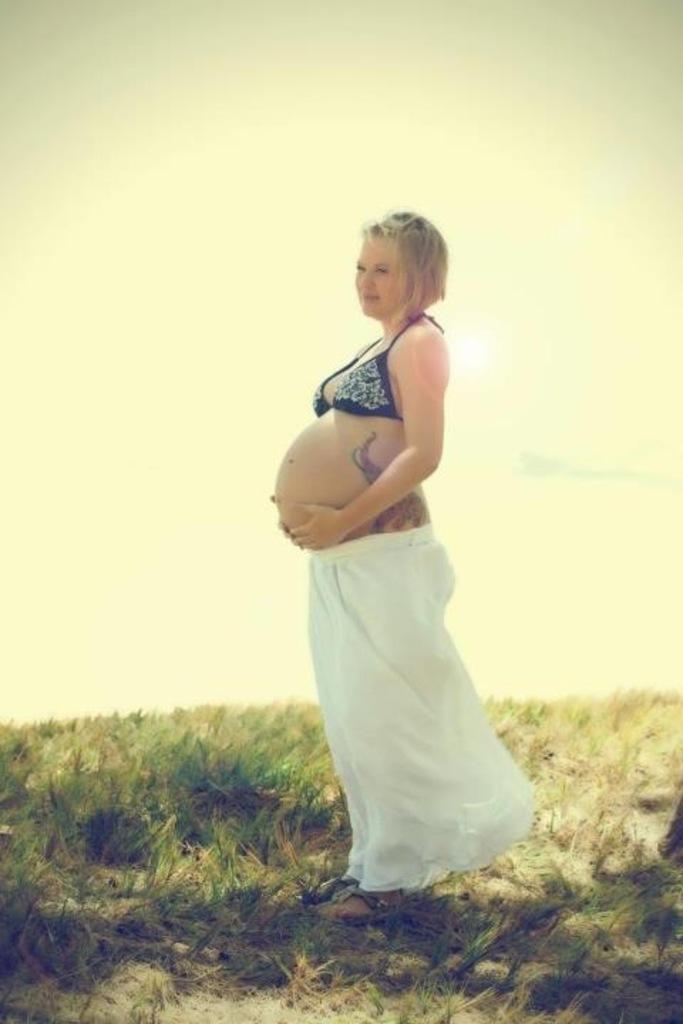How would you summarize this image in a sentence or two? In this image I can see the person is standing and wearing black and white color dress. I can see the grass and the sky. 